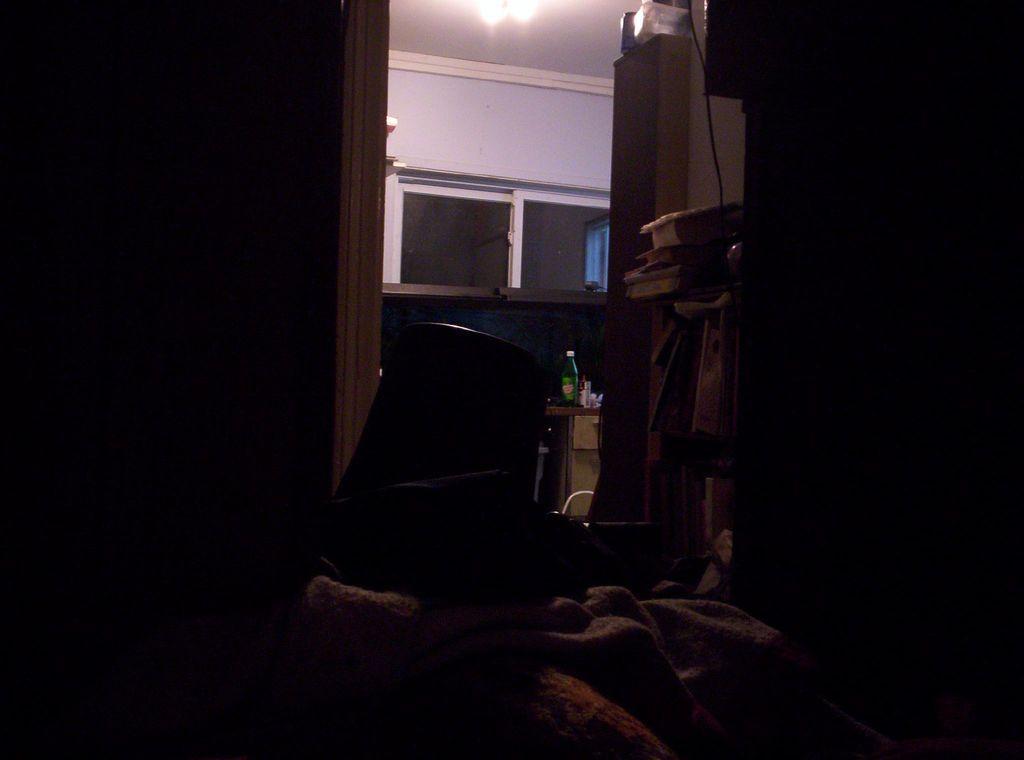In one or two sentences, can you explain what this image depicts? This is window, wall and light. 